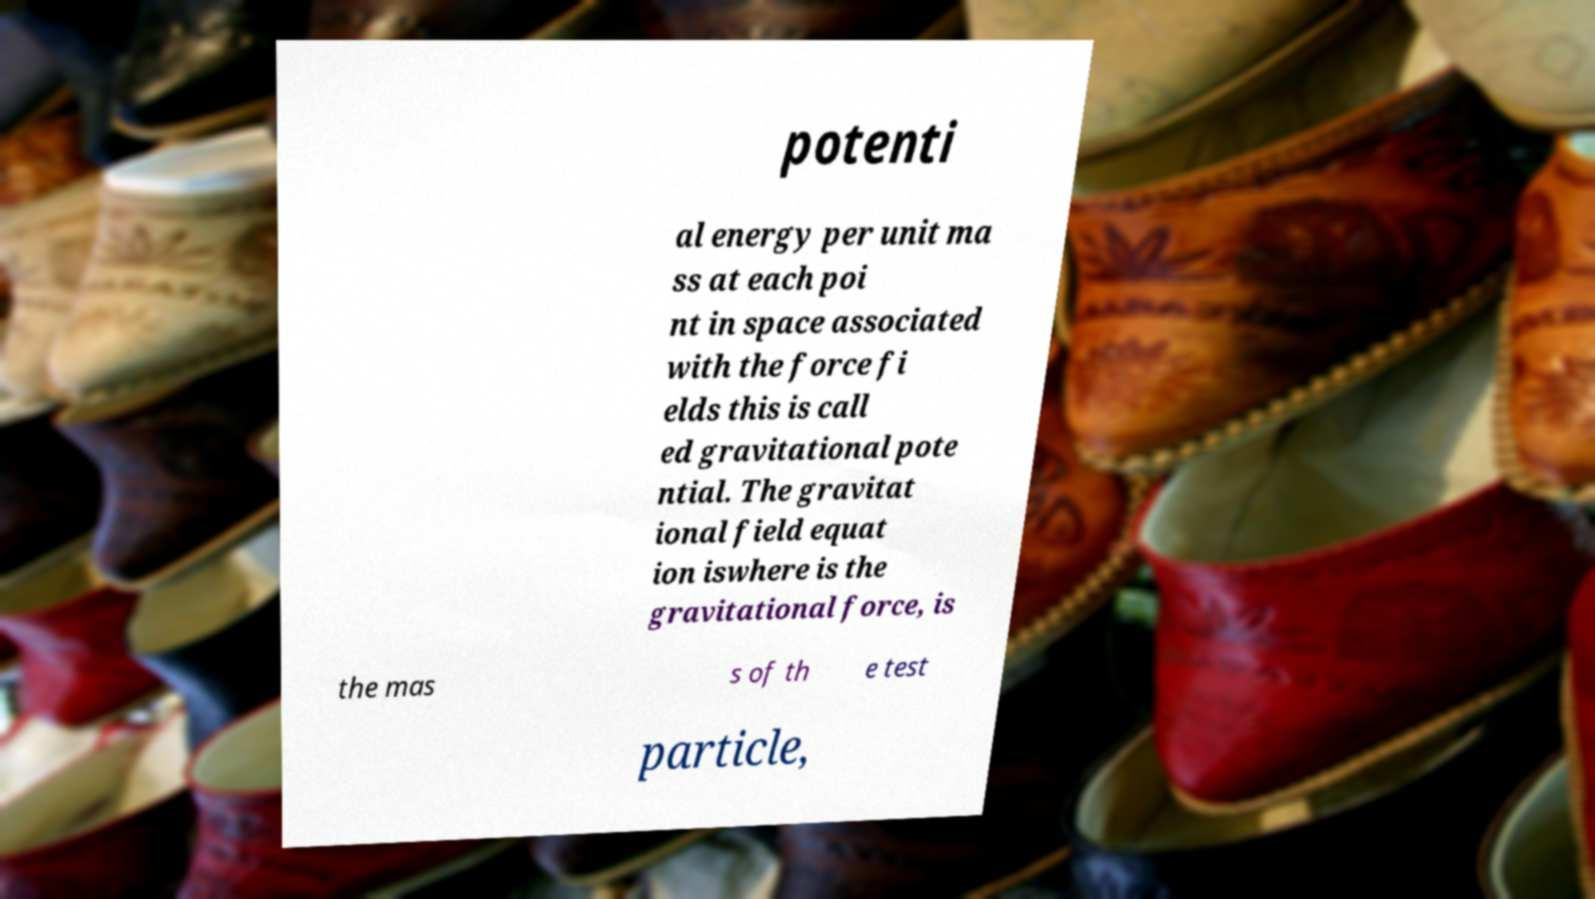There's text embedded in this image that I need extracted. Can you transcribe it verbatim? potenti al energy per unit ma ss at each poi nt in space associated with the force fi elds this is call ed gravitational pote ntial. The gravitat ional field equat ion iswhere is the gravitational force, is the mas s of th e test particle, 